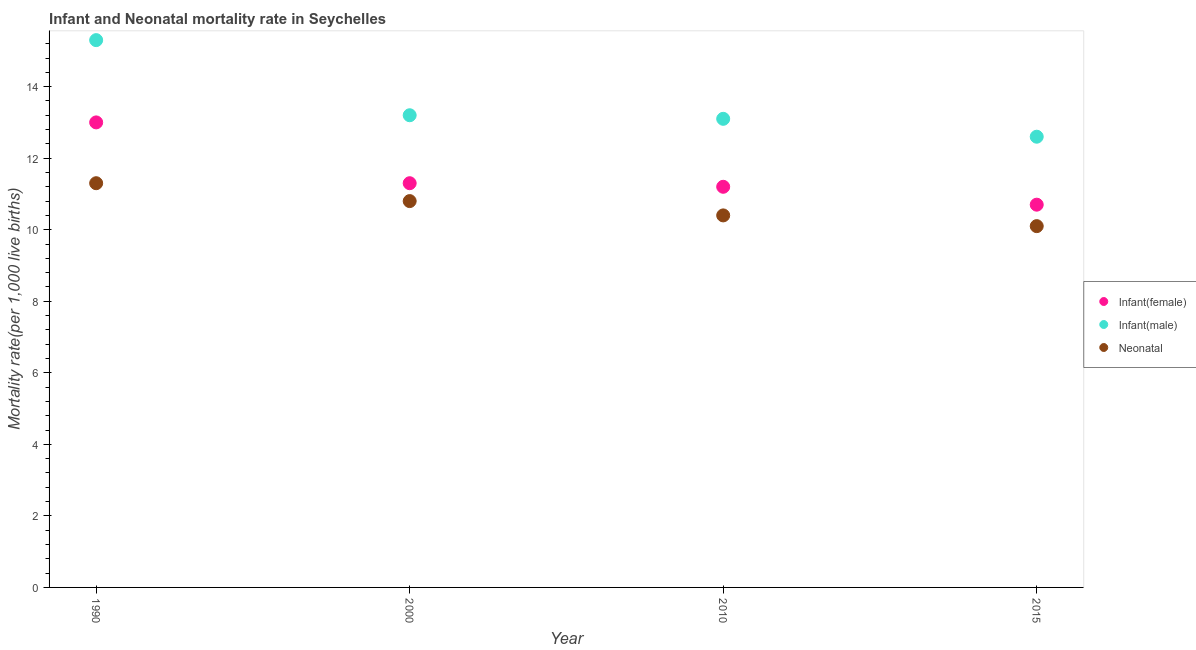How many different coloured dotlines are there?
Give a very brief answer. 3. Across all years, what is the minimum infant mortality rate(male)?
Ensure brevity in your answer.  12.6. In which year was the infant mortality rate(female) minimum?
Your response must be concise. 2015. What is the total infant mortality rate(male) in the graph?
Provide a succinct answer. 54.2. What is the difference between the neonatal mortality rate in 2000 and that in 2010?
Make the answer very short. 0.4. What is the difference between the infant mortality rate(female) in 2010 and the infant mortality rate(male) in 2000?
Provide a short and direct response. -2. What is the average infant mortality rate(female) per year?
Your answer should be compact. 11.55. In the year 2000, what is the difference between the infant mortality rate(male) and neonatal mortality rate?
Your response must be concise. 2.4. In how many years, is the infant mortality rate(female) greater than 4.4?
Your answer should be compact. 4. What is the ratio of the infant mortality rate(female) in 2010 to that in 2015?
Make the answer very short. 1.05. Is the infant mortality rate(male) in 2010 less than that in 2015?
Keep it short and to the point. No. Is the difference between the infant mortality rate(female) in 1990 and 2000 greater than the difference between the infant mortality rate(male) in 1990 and 2000?
Your answer should be compact. No. What is the difference between the highest and the second highest infant mortality rate(female)?
Ensure brevity in your answer.  1.7. What is the difference between the highest and the lowest infant mortality rate(female)?
Provide a short and direct response. 2.3. In how many years, is the infant mortality rate(female) greater than the average infant mortality rate(female) taken over all years?
Provide a succinct answer. 1. Is the sum of the neonatal mortality rate in 1990 and 2015 greater than the maximum infant mortality rate(male) across all years?
Your answer should be compact. Yes. Does the neonatal mortality rate monotonically increase over the years?
Your answer should be very brief. No. Is the neonatal mortality rate strictly greater than the infant mortality rate(female) over the years?
Your answer should be very brief. No. Is the infant mortality rate(male) strictly less than the neonatal mortality rate over the years?
Offer a very short reply. No. How many dotlines are there?
Provide a succinct answer. 3. How many years are there in the graph?
Offer a terse response. 4. Are the values on the major ticks of Y-axis written in scientific E-notation?
Your answer should be compact. No. Does the graph contain any zero values?
Provide a short and direct response. No. Does the graph contain grids?
Make the answer very short. No. Where does the legend appear in the graph?
Make the answer very short. Center right. How many legend labels are there?
Make the answer very short. 3. What is the title of the graph?
Your answer should be compact. Infant and Neonatal mortality rate in Seychelles. Does "Errors" appear as one of the legend labels in the graph?
Offer a very short reply. No. What is the label or title of the X-axis?
Provide a short and direct response. Year. What is the label or title of the Y-axis?
Ensure brevity in your answer.  Mortality rate(per 1,0 live births). What is the Mortality rate(per 1,000 live births) of Infant(female) in 1990?
Provide a short and direct response. 13. What is the Mortality rate(per 1,000 live births) in Infant(male) in 1990?
Offer a very short reply. 15.3. What is the Mortality rate(per 1,000 live births) in Infant(female) in 2000?
Your answer should be compact. 11.3. What is the Mortality rate(per 1,000 live births) of Neonatal  in 2015?
Your answer should be very brief. 10.1. Across all years, what is the minimum Mortality rate(per 1,000 live births) in Infant(female)?
Provide a succinct answer. 10.7. Across all years, what is the minimum Mortality rate(per 1,000 live births) of Infant(male)?
Give a very brief answer. 12.6. What is the total Mortality rate(per 1,000 live births) of Infant(female) in the graph?
Provide a short and direct response. 46.2. What is the total Mortality rate(per 1,000 live births) in Infant(male) in the graph?
Make the answer very short. 54.2. What is the total Mortality rate(per 1,000 live births) in Neonatal  in the graph?
Keep it short and to the point. 42.6. What is the difference between the Mortality rate(per 1,000 live births) of Infant(female) in 1990 and that in 2000?
Offer a terse response. 1.7. What is the difference between the Mortality rate(per 1,000 live births) in Neonatal  in 1990 and that in 2000?
Your answer should be compact. 0.5. What is the difference between the Mortality rate(per 1,000 live births) of Infant(female) in 1990 and that in 2010?
Give a very brief answer. 1.8. What is the difference between the Mortality rate(per 1,000 live births) in Infant(male) in 1990 and that in 2010?
Ensure brevity in your answer.  2.2. What is the difference between the Mortality rate(per 1,000 live births) of Neonatal  in 1990 and that in 2010?
Give a very brief answer. 0.9. What is the difference between the Mortality rate(per 1,000 live births) in Neonatal  in 1990 and that in 2015?
Ensure brevity in your answer.  1.2. What is the difference between the Mortality rate(per 1,000 live births) of Neonatal  in 2000 and that in 2015?
Give a very brief answer. 0.7. What is the difference between the Mortality rate(per 1,000 live births) of Infant(female) in 2010 and that in 2015?
Your response must be concise. 0.5. What is the difference between the Mortality rate(per 1,000 live births) of Infant(male) in 2010 and that in 2015?
Provide a succinct answer. 0.5. What is the difference between the Mortality rate(per 1,000 live births) of Infant(male) in 1990 and the Mortality rate(per 1,000 live births) of Neonatal  in 2000?
Ensure brevity in your answer.  4.5. What is the difference between the Mortality rate(per 1,000 live births) of Infant(female) in 1990 and the Mortality rate(per 1,000 live births) of Neonatal  in 2010?
Make the answer very short. 2.6. What is the difference between the Mortality rate(per 1,000 live births) of Infant(male) in 1990 and the Mortality rate(per 1,000 live births) of Neonatal  in 2010?
Make the answer very short. 4.9. What is the difference between the Mortality rate(per 1,000 live births) of Infant(female) in 2000 and the Mortality rate(per 1,000 live births) of Neonatal  in 2010?
Provide a short and direct response. 0.9. What is the difference between the Mortality rate(per 1,000 live births) in Infant(female) in 2010 and the Mortality rate(per 1,000 live births) in Infant(male) in 2015?
Provide a succinct answer. -1.4. What is the difference between the Mortality rate(per 1,000 live births) in Infant(male) in 2010 and the Mortality rate(per 1,000 live births) in Neonatal  in 2015?
Your response must be concise. 3. What is the average Mortality rate(per 1,000 live births) in Infant(female) per year?
Your answer should be compact. 11.55. What is the average Mortality rate(per 1,000 live births) in Infant(male) per year?
Offer a very short reply. 13.55. What is the average Mortality rate(per 1,000 live births) of Neonatal  per year?
Give a very brief answer. 10.65. In the year 1990, what is the difference between the Mortality rate(per 1,000 live births) of Infant(female) and Mortality rate(per 1,000 live births) of Infant(male)?
Provide a short and direct response. -2.3. In the year 1990, what is the difference between the Mortality rate(per 1,000 live births) in Infant(female) and Mortality rate(per 1,000 live births) in Neonatal ?
Your answer should be compact. 1.7. In the year 2000, what is the difference between the Mortality rate(per 1,000 live births) in Infant(female) and Mortality rate(per 1,000 live births) in Infant(male)?
Provide a succinct answer. -1.9. In the year 2000, what is the difference between the Mortality rate(per 1,000 live births) in Infant(female) and Mortality rate(per 1,000 live births) in Neonatal ?
Ensure brevity in your answer.  0.5. In the year 2000, what is the difference between the Mortality rate(per 1,000 live births) of Infant(male) and Mortality rate(per 1,000 live births) of Neonatal ?
Your answer should be compact. 2.4. In the year 2010, what is the difference between the Mortality rate(per 1,000 live births) in Infant(female) and Mortality rate(per 1,000 live births) in Neonatal ?
Make the answer very short. 0.8. In the year 2015, what is the difference between the Mortality rate(per 1,000 live births) of Infant(female) and Mortality rate(per 1,000 live births) of Neonatal ?
Offer a very short reply. 0.6. In the year 2015, what is the difference between the Mortality rate(per 1,000 live births) of Infant(male) and Mortality rate(per 1,000 live births) of Neonatal ?
Ensure brevity in your answer.  2.5. What is the ratio of the Mortality rate(per 1,000 live births) of Infant(female) in 1990 to that in 2000?
Make the answer very short. 1.15. What is the ratio of the Mortality rate(per 1,000 live births) of Infant(male) in 1990 to that in 2000?
Offer a very short reply. 1.16. What is the ratio of the Mortality rate(per 1,000 live births) of Neonatal  in 1990 to that in 2000?
Offer a very short reply. 1.05. What is the ratio of the Mortality rate(per 1,000 live births) in Infant(female) in 1990 to that in 2010?
Make the answer very short. 1.16. What is the ratio of the Mortality rate(per 1,000 live births) in Infant(male) in 1990 to that in 2010?
Your answer should be very brief. 1.17. What is the ratio of the Mortality rate(per 1,000 live births) of Neonatal  in 1990 to that in 2010?
Give a very brief answer. 1.09. What is the ratio of the Mortality rate(per 1,000 live births) in Infant(female) in 1990 to that in 2015?
Your response must be concise. 1.22. What is the ratio of the Mortality rate(per 1,000 live births) in Infant(male) in 1990 to that in 2015?
Provide a short and direct response. 1.21. What is the ratio of the Mortality rate(per 1,000 live births) of Neonatal  in 1990 to that in 2015?
Your answer should be compact. 1.12. What is the ratio of the Mortality rate(per 1,000 live births) in Infant(female) in 2000 to that in 2010?
Offer a terse response. 1.01. What is the ratio of the Mortality rate(per 1,000 live births) in Infant(male) in 2000 to that in 2010?
Ensure brevity in your answer.  1.01. What is the ratio of the Mortality rate(per 1,000 live births) in Neonatal  in 2000 to that in 2010?
Provide a succinct answer. 1.04. What is the ratio of the Mortality rate(per 1,000 live births) in Infant(female) in 2000 to that in 2015?
Keep it short and to the point. 1.06. What is the ratio of the Mortality rate(per 1,000 live births) in Infant(male) in 2000 to that in 2015?
Give a very brief answer. 1.05. What is the ratio of the Mortality rate(per 1,000 live births) of Neonatal  in 2000 to that in 2015?
Provide a succinct answer. 1.07. What is the ratio of the Mortality rate(per 1,000 live births) in Infant(female) in 2010 to that in 2015?
Keep it short and to the point. 1.05. What is the ratio of the Mortality rate(per 1,000 live births) in Infant(male) in 2010 to that in 2015?
Ensure brevity in your answer.  1.04. What is the ratio of the Mortality rate(per 1,000 live births) of Neonatal  in 2010 to that in 2015?
Ensure brevity in your answer.  1.03. What is the difference between the highest and the second highest Mortality rate(per 1,000 live births) in Infant(female)?
Your answer should be very brief. 1.7. What is the difference between the highest and the lowest Mortality rate(per 1,000 live births) of Infant(female)?
Offer a terse response. 2.3. What is the difference between the highest and the lowest Mortality rate(per 1,000 live births) in Neonatal ?
Ensure brevity in your answer.  1.2. 